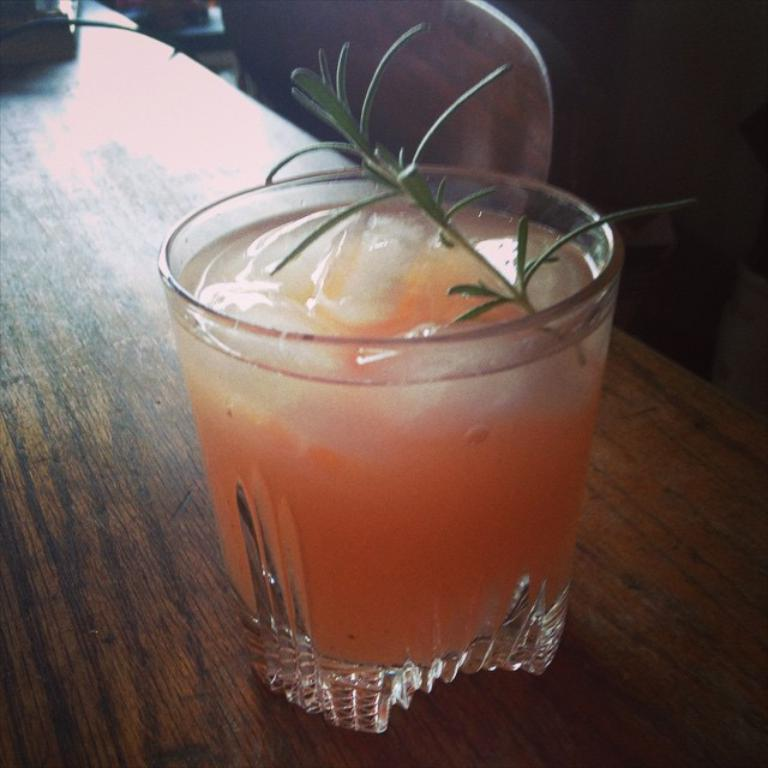What piece of furniture is present in the image? There is a table in the image. What is on the table in the image? There is a glass with a drink in it on the table. How many trees are visible in the image? There are no trees visible in the image; it only features a table and a glass with a drink in it. What type of hook is used to hold the glass in the image? There is no hook present in the image; the glass is simply sitting on the table. 